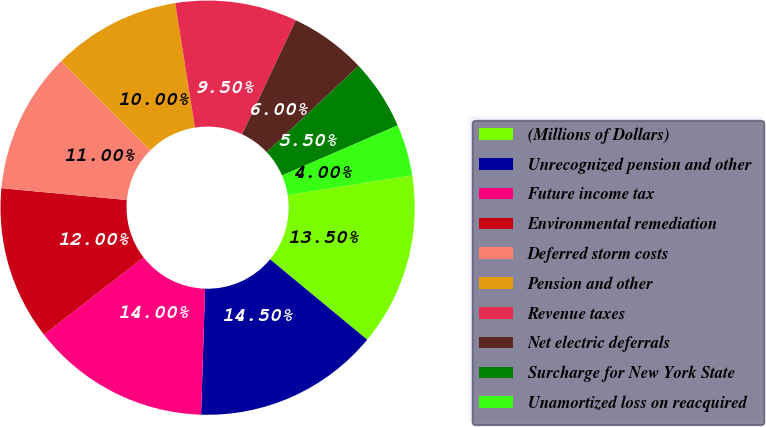Convert chart. <chart><loc_0><loc_0><loc_500><loc_500><pie_chart><fcel>(Millions of Dollars)<fcel>Unrecognized pension and other<fcel>Future income tax<fcel>Environmental remediation<fcel>Deferred storm costs<fcel>Pension and other<fcel>Revenue taxes<fcel>Net electric deferrals<fcel>Surcharge for New York State<fcel>Unamortized loss on reacquired<nl><fcel>13.5%<fcel>14.5%<fcel>14.0%<fcel>12.0%<fcel>11.0%<fcel>10.0%<fcel>9.5%<fcel>6.0%<fcel>5.5%<fcel>4.0%<nl></chart> 